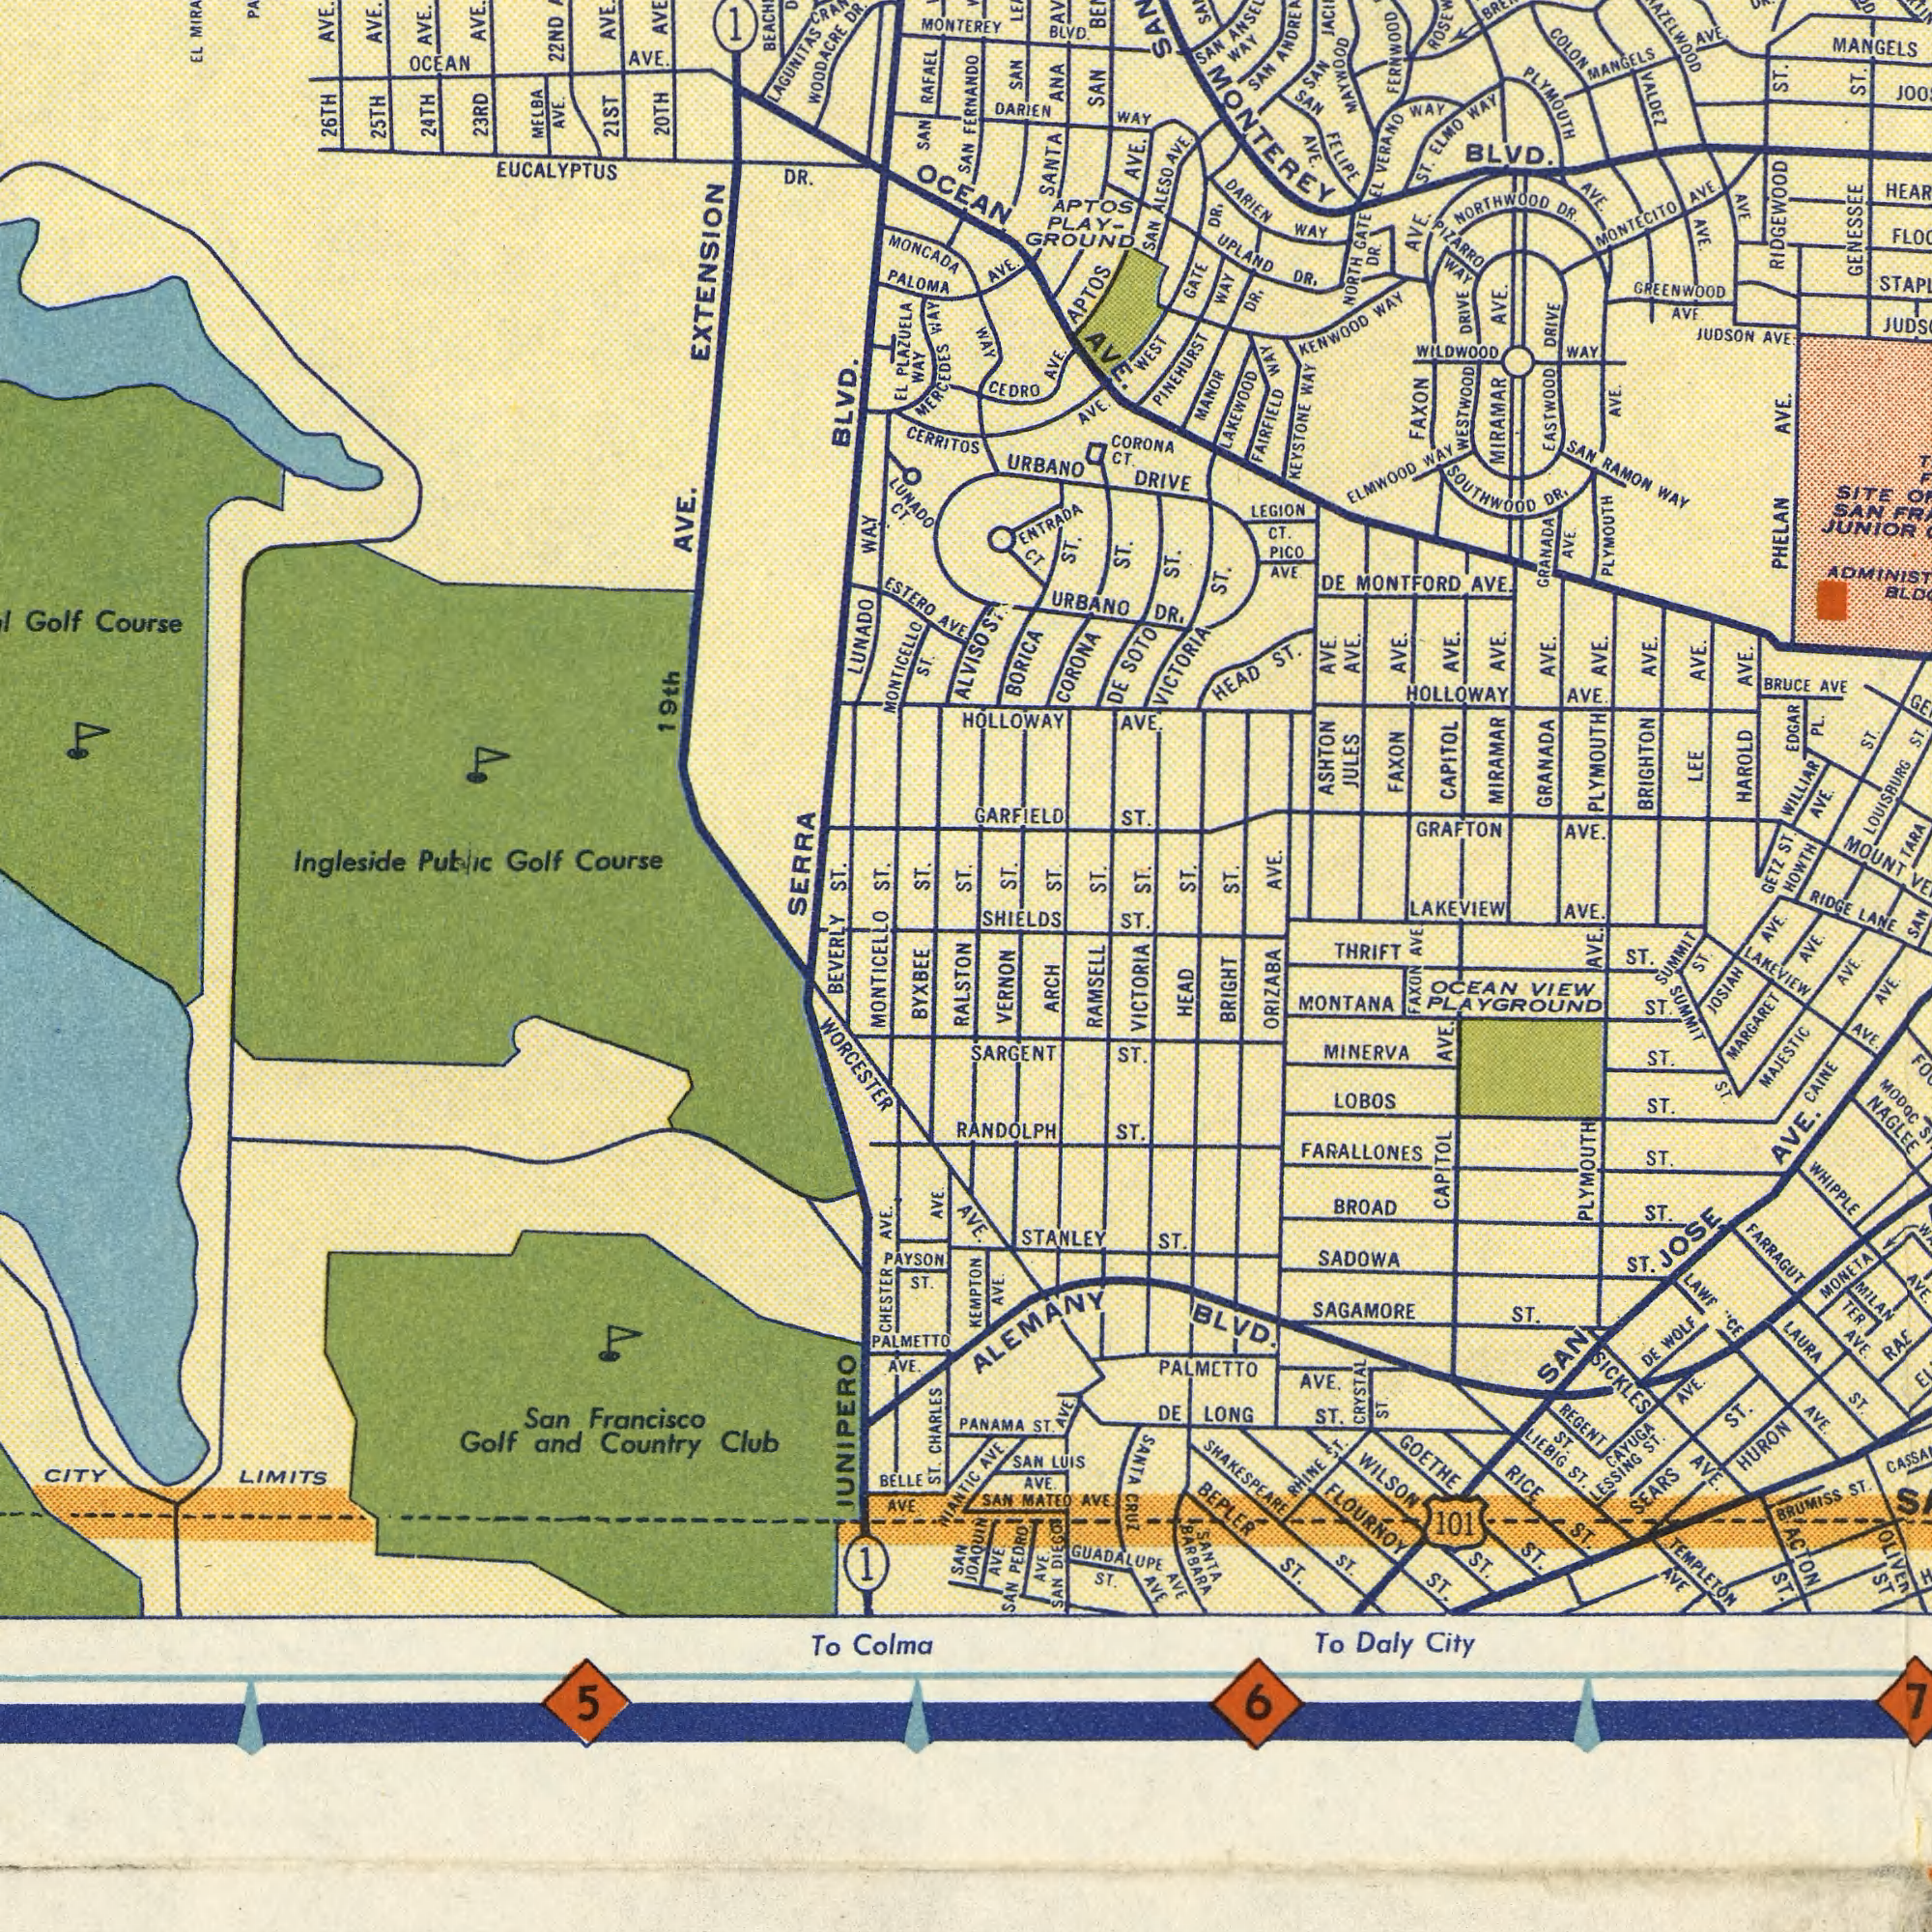What text is visible in the upper-right corner? RIDGEWOOD GENESSEE MIRAMAR CAPITOL MIRAMAR BLVD. EASTWOOD PLYMOUTH MANGELS GRANADA NORTHWOOD PINEHURST FERNWOOD LOUISBURG AVE. HOLLOWAY APTOS SANTA LEE GREENWOOD MAYWOOD URBANO ST. AVE. PLYMOUTH PLYMOUTH GRAFTON CORONA ST. ST. MONTECITO WAY AVE. AVE. ST. AVE. SOUTHWOOD FAXON ST. DR. AVE. GARFIELD AVE. ST. AVE. JUDSON AVE. WAY NEYSTONE MONTFORD HEAD AVE. AVE. AVE. ENTRADA CORONA AVE. ST. AVE. SAN MOUNT RAMON VICTORIA ANA AVE. AVE. SAN BORICA AVE. HOLLOWAY ST. VERANO DRIVE ST. JULES DR. URBANO FAXON KENWOOD AVE. ST. AVE. WAY SAN AVE. BRUCE LAKEWOOD ASHTON BLVD. SAN SAN WAY SAN COLON MANGELS AVE. MONTEREY VALDEZ DARIEN WAY ALESO AVE. DARIEN AVE. SAN FELIPE EL GATE NORTH DR. AVE. WAY DR. DR. UPLAND GATE WAY WAY ELMO WAY PLZARRO WAY DR. DRIVE DRIVE WAY WILDWOOD WESTWOOD WAY ELMWOOD AVE. AVE. AVE. PLAY- GROUND APTOS WAY CEDRO AVE. FAIRFIELD SAN WAY CT. AVE. WEST MANOR CT. ST. LEGION CT. PICO AVE. DE GRANADA PHELAN SITE SAN JUNIOR ST. DR. DE SOTO AVE. AVE. AVE. AVE. AVE. BRIGHTON HAROLD EDGAR PL. AVE WILLIAR ST. TARA What text is shown in the bottom-right quadrant? LAKEVIEW ST. AVE. LANE ST. RIDGE AVE. THRIFT SARGENT FARALLONES ALEMANY AVE. REGENT MINERVA SAN LOBOS GOETHE RANDOLPH WHIPPLE BROAD MONTANA ST. VERNON RICE FLOURNOY RAMSELL STANLEY WILSON CAPITOL BEPLER NAGLEE ST. SAN ST. BRIGHT PLYMOUTH BLVD. WOLF MARGARET SAGAMORE PALMCTTO SICKLES SADOWA AVE. VICTORIA SEARS MONETA AVE. AVE. ST. MAJESTIC ST. ST. HURON AVE. SANTA ST. Daly BRUMISS ARCH PEDRO ACTON ST. ST. ORIZABA ST. 101 CRYSTAL LONG AVE. ST. AVE ST. DE JOSIAH ST. AVE. AVE CRUZ LAURA LUIS City AVE ST. SAN ST. ST. AVE. ST. GUADALUPE ST. LESSING RAE AVE. TER ST. ST. SHAKESPEARE To AVE ST. FARRAGUT PLAYGROUND RHINE SAN CAINE ST. ST. SHIELDS ST. ST. ST. AVE. GETZ HOWTH AVE. SAN HEAD FAXON VIEW OCEAN AVE. ST. SUMMIT ST. SUMMIT LAKEVIEV AVE. AVE. ST. ST. ST. MODOC ST. ST. JOSE AVE. MILAN PANAMA ST. AVE. DE AVE. ST. ST. LIEBIG CAYUGA AVE. DIEGO AVE. SAN MATEO AVE. SANTA BARBARA 6 TEMPLETON AVE ST. 7 What text can you see in the top-left section? Ingleside BLVD. EUCALYPTUS 22ND AVE. 24TH 21ST Course 23RD WAY LUNADO RAFAEL AVE. MELBA AVE. SAN OCEAN AVE. 25TH AVE. MONCADA 26TH PLAZUELA DR. LUNADO AVE. Course MONTEREY CERRITOS Public Golf EXTENSION EL MONTICELLO PALOMA EL ESTERO AVE. MERCEDES LAGUNITAS 19th DR. Golf SERRA OCEAN ST. AVE. WOODACRE WAY 20TH AVE. 1 SAN FERNANDO WAY CT. ALVISO What text can you see in the bottom-left section? ST. ST. BEVERLY ST. JUNIPERO Francisco PALMETTO WORCESTER LIMITS AVE. San ST. BYXBEE AVE. Country CITY MONTICELLO Colma CHESTER AVE. BELLE 5 Club CHARLES To Golf ST. RALSTON and PAYSON AVE SAN 1 KEMPTON JOAQUIN ST. AVE. NIANTIC 